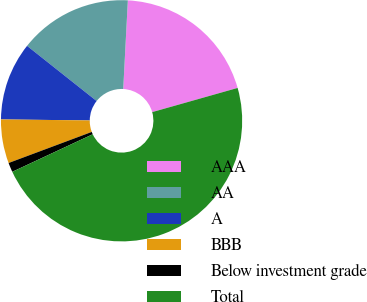Convert chart to OTSL. <chart><loc_0><loc_0><loc_500><loc_500><pie_chart><fcel>AAA<fcel>AA<fcel>A<fcel>BBB<fcel>Below investment grade<fcel>Total<nl><fcel>19.78%<fcel>15.16%<fcel>10.49%<fcel>5.87%<fcel>1.26%<fcel>47.44%<nl></chart> 